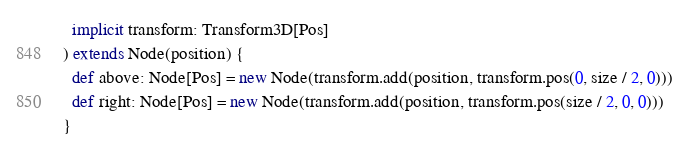Convert code to text. <code><loc_0><loc_0><loc_500><loc_500><_Scala_>  implicit transform: Transform3D[Pos]
) extends Node(position) {
  def above: Node[Pos] = new Node(transform.add(position, transform.pos(0, size / 2, 0)))
  def right: Node[Pos] = new Node(transform.add(position, transform.pos(size / 2, 0, 0)))
}
</code> 